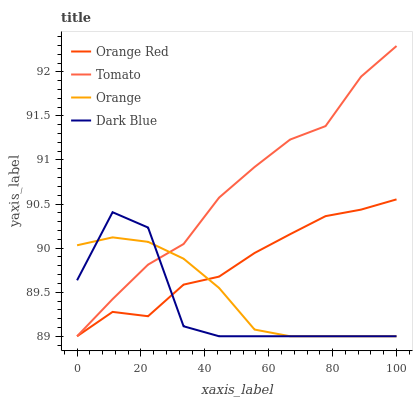Does Dark Blue have the minimum area under the curve?
Answer yes or no. Yes. Does Tomato have the maximum area under the curve?
Answer yes or no. Yes. Does Orange have the minimum area under the curve?
Answer yes or no. No. Does Orange have the maximum area under the curve?
Answer yes or no. No. Is Orange the smoothest?
Answer yes or no. Yes. Is Dark Blue the roughest?
Answer yes or no. Yes. Is Orange Red the smoothest?
Answer yes or no. No. Is Orange Red the roughest?
Answer yes or no. No. Does Tomato have the lowest value?
Answer yes or no. Yes. Does Tomato have the highest value?
Answer yes or no. Yes. Does Orange Red have the highest value?
Answer yes or no. No. Does Orange Red intersect Dark Blue?
Answer yes or no. Yes. Is Orange Red less than Dark Blue?
Answer yes or no. No. Is Orange Red greater than Dark Blue?
Answer yes or no. No. 